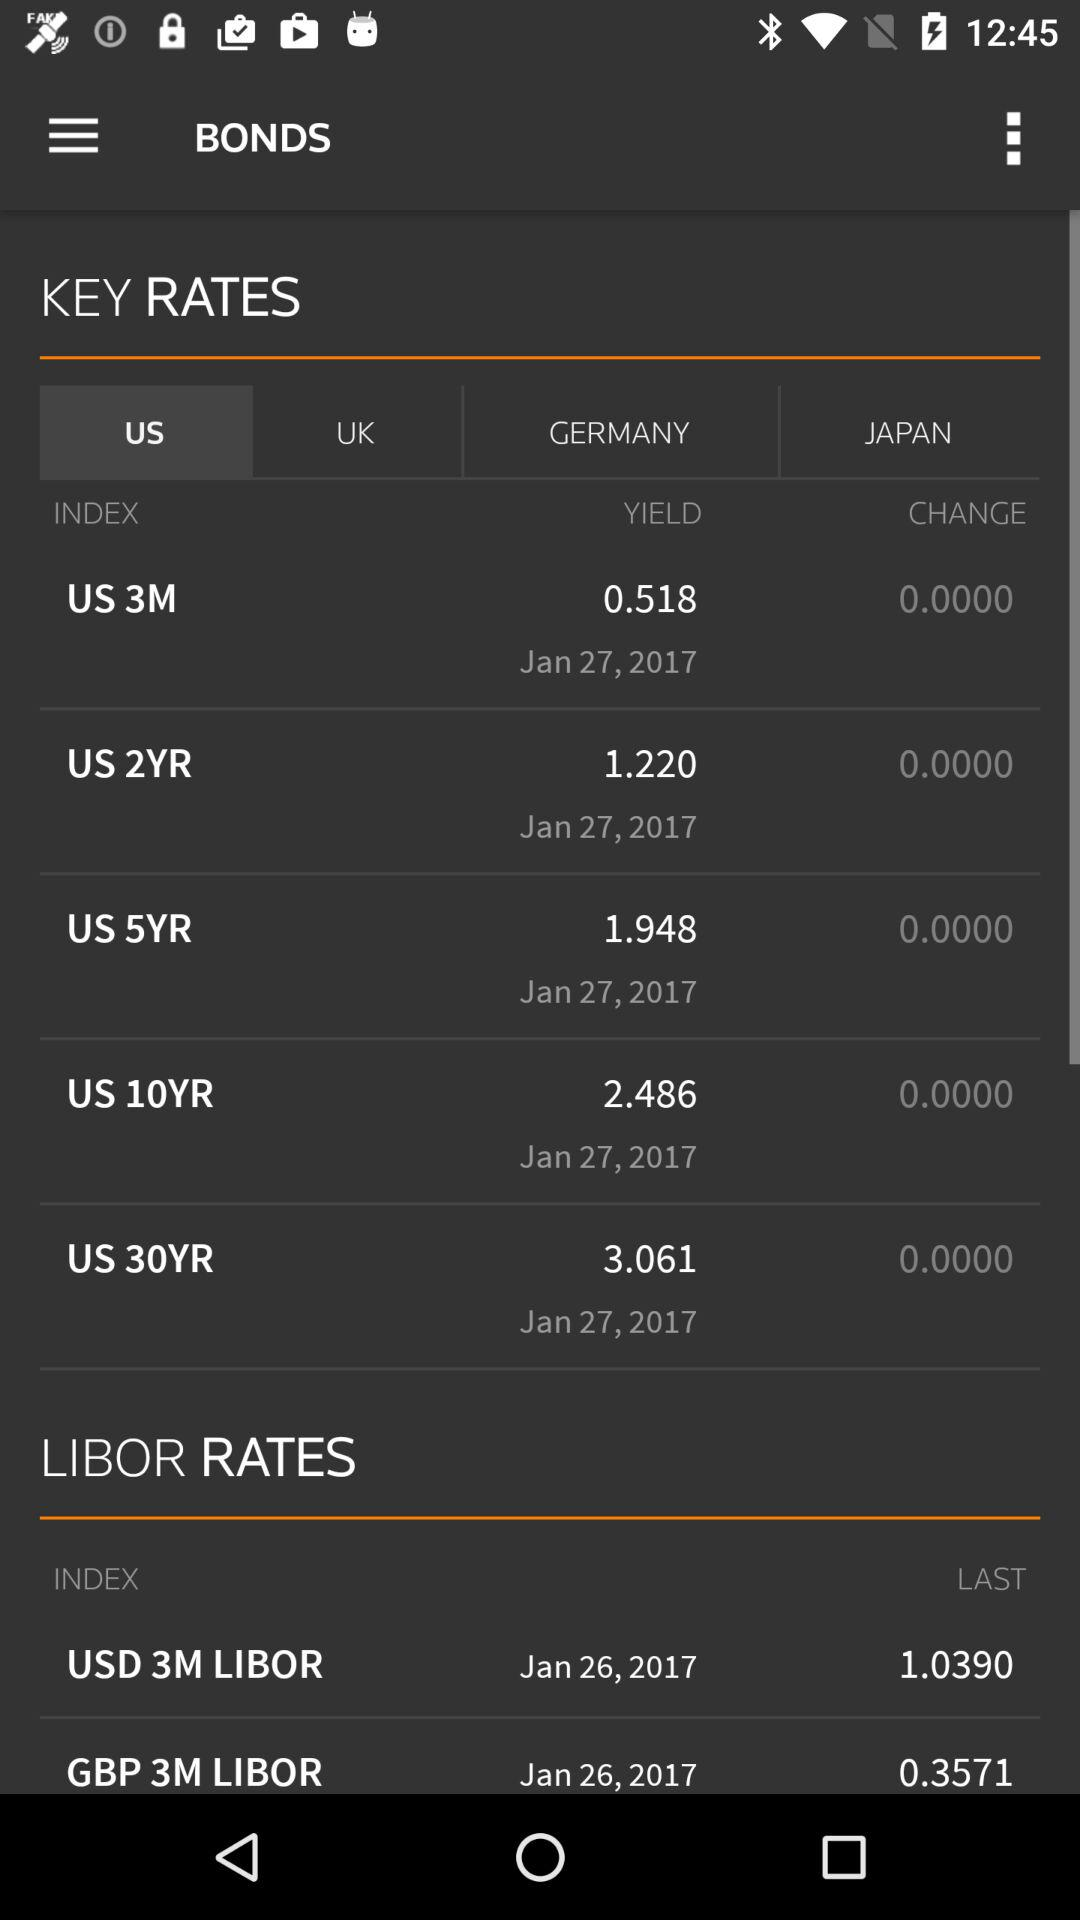What is the date of the latest LIBOR rate?
Answer the question using a single word or phrase. Jan 26, 2017 